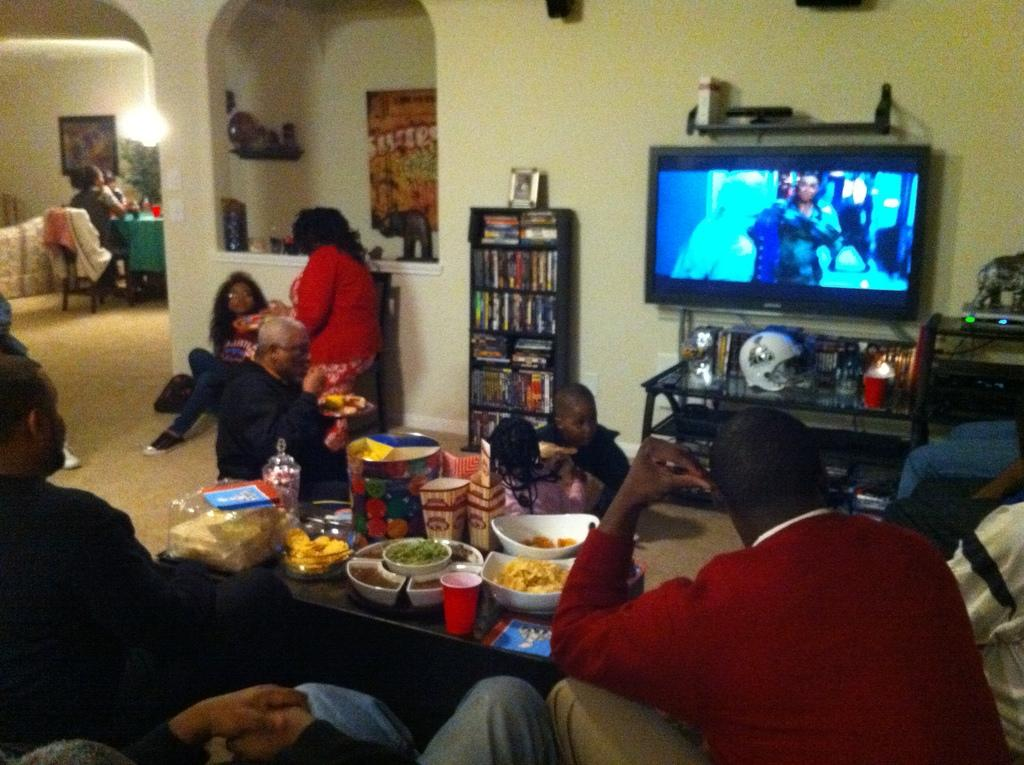What are the people in the image doing? The people in the image are seated on chairs. What electronic device can be seen in the image? There is a television in the image. What type of furniture is present in the image for storing items? There is a bookshelf in the image. What can be found on the table in the image? There are food items, bowls, and glasses on the table in the image. What type of tramp is visible in the image? There is no tramp present in the image. How many family members can be seen in the image? The provided facts do not mention the number of family members or any family members at all, so it cannot be determined from the image. 